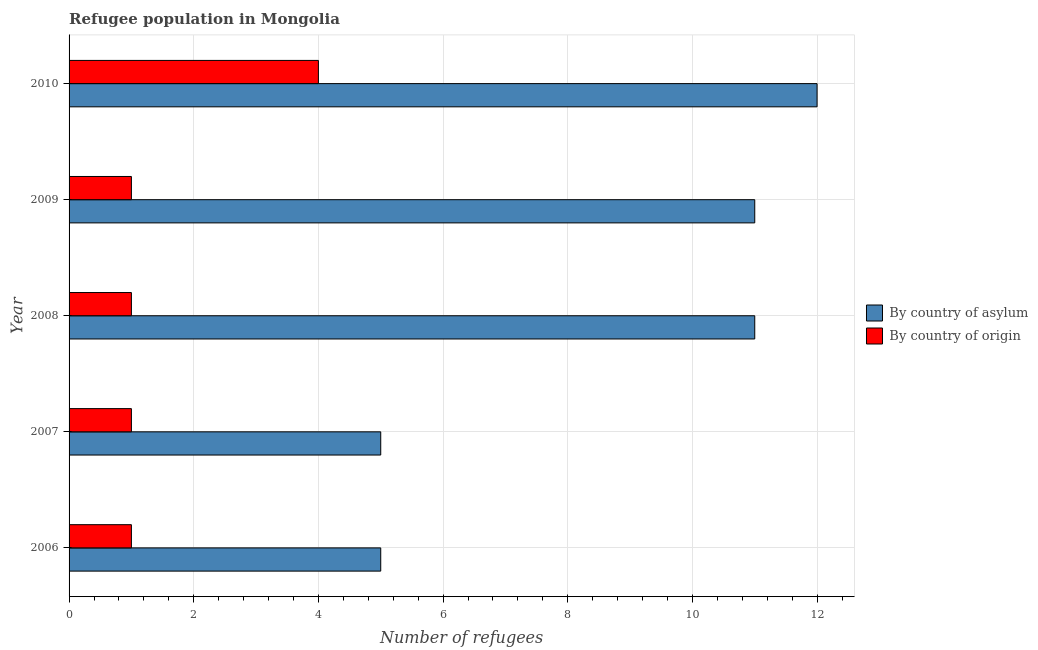How many different coloured bars are there?
Offer a very short reply. 2. How many groups of bars are there?
Offer a very short reply. 5. Are the number of bars per tick equal to the number of legend labels?
Ensure brevity in your answer.  Yes. How many bars are there on the 2nd tick from the top?
Keep it short and to the point. 2. In how many cases, is the number of bars for a given year not equal to the number of legend labels?
Your response must be concise. 0. What is the number of refugees by country of origin in 2008?
Your answer should be very brief. 1. Across all years, what is the maximum number of refugees by country of origin?
Your response must be concise. 4. Across all years, what is the minimum number of refugees by country of origin?
Give a very brief answer. 1. In which year was the number of refugees by country of origin maximum?
Your response must be concise. 2010. In which year was the number of refugees by country of asylum minimum?
Provide a short and direct response. 2006. What is the total number of refugees by country of asylum in the graph?
Your answer should be very brief. 44. What is the difference between the number of refugees by country of asylum in 2007 and that in 2008?
Your response must be concise. -6. What is the difference between the number of refugees by country of asylum in 2009 and the number of refugees by country of origin in 2010?
Offer a very short reply. 7. In the year 2006, what is the difference between the number of refugees by country of asylum and number of refugees by country of origin?
Your response must be concise. 4. In how many years, is the number of refugees by country of origin greater than 9.6 ?
Your answer should be compact. 0. Is the difference between the number of refugees by country of origin in 2009 and 2010 greater than the difference between the number of refugees by country of asylum in 2009 and 2010?
Ensure brevity in your answer.  No. What is the difference between the highest and the lowest number of refugees by country of asylum?
Keep it short and to the point. 7. What does the 2nd bar from the top in 2009 represents?
Offer a terse response. By country of asylum. What does the 1st bar from the bottom in 2006 represents?
Give a very brief answer. By country of asylum. How many bars are there?
Make the answer very short. 10. Are all the bars in the graph horizontal?
Your answer should be very brief. Yes. How many years are there in the graph?
Keep it short and to the point. 5. Does the graph contain any zero values?
Provide a succinct answer. No. Where does the legend appear in the graph?
Provide a succinct answer. Center right. How are the legend labels stacked?
Provide a succinct answer. Vertical. What is the title of the graph?
Your answer should be compact. Refugee population in Mongolia. What is the label or title of the X-axis?
Offer a very short reply. Number of refugees. What is the label or title of the Y-axis?
Keep it short and to the point. Year. What is the Number of refugees of By country of asylum in 2006?
Your answer should be compact. 5. What is the Number of refugees of By country of asylum in 2007?
Provide a succinct answer. 5. What is the Number of refugees in By country of origin in 2007?
Provide a succinct answer. 1. What is the Number of refugees of By country of origin in 2008?
Keep it short and to the point. 1. What is the Number of refugees in By country of asylum in 2009?
Your answer should be very brief. 11. What is the Number of refugees in By country of origin in 2009?
Provide a succinct answer. 1. What is the Number of refugees of By country of asylum in 2010?
Make the answer very short. 12. Across all years, what is the maximum Number of refugees in By country of asylum?
Provide a succinct answer. 12. Across all years, what is the maximum Number of refugees of By country of origin?
Ensure brevity in your answer.  4. Across all years, what is the minimum Number of refugees in By country of asylum?
Offer a very short reply. 5. Across all years, what is the minimum Number of refugees of By country of origin?
Provide a succinct answer. 1. What is the difference between the Number of refugees in By country of origin in 2006 and that in 2007?
Your answer should be very brief. 0. What is the difference between the Number of refugees in By country of asylum in 2006 and that in 2009?
Your answer should be very brief. -6. What is the difference between the Number of refugees in By country of asylum in 2006 and that in 2010?
Your response must be concise. -7. What is the difference between the Number of refugees of By country of origin in 2007 and that in 2008?
Ensure brevity in your answer.  0. What is the difference between the Number of refugees of By country of asylum in 2007 and that in 2009?
Your answer should be very brief. -6. What is the difference between the Number of refugees in By country of origin in 2007 and that in 2009?
Offer a very short reply. 0. What is the difference between the Number of refugees in By country of origin in 2007 and that in 2010?
Your answer should be compact. -3. What is the difference between the Number of refugees of By country of origin in 2008 and that in 2009?
Keep it short and to the point. 0. What is the difference between the Number of refugees in By country of asylum in 2009 and that in 2010?
Offer a terse response. -1. What is the difference between the Number of refugees of By country of origin in 2009 and that in 2010?
Provide a short and direct response. -3. What is the difference between the Number of refugees of By country of asylum in 2006 and the Number of refugees of By country of origin in 2007?
Your answer should be very brief. 4. What is the difference between the Number of refugees in By country of asylum in 2006 and the Number of refugees in By country of origin in 2008?
Provide a succinct answer. 4. What is the difference between the Number of refugees in By country of asylum in 2006 and the Number of refugees in By country of origin in 2009?
Offer a terse response. 4. What is the difference between the Number of refugees of By country of asylum in 2007 and the Number of refugees of By country of origin in 2010?
Give a very brief answer. 1. What is the difference between the Number of refugees of By country of asylum in 2009 and the Number of refugees of By country of origin in 2010?
Ensure brevity in your answer.  7. What is the average Number of refugees in By country of asylum per year?
Offer a terse response. 8.8. What is the average Number of refugees in By country of origin per year?
Your answer should be compact. 1.6. In the year 2007, what is the difference between the Number of refugees of By country of asylum and Number of refugees of By country of origin?
Give a very brief answer. 4. In the year 2008, what is the difference between the Number of refugees in By country of asylum and Number of refugees in By country of origin?
Give a very brief answer. 10. In the year 2010, what is the difference between the Number of refugees in By country of asylum and Number of refugees in By country of origin?
Provide a succinct answer. 8. What is the ratio of the Number of refugees of By country of asylum in 2006 to that in 2007?
Offer a very short reply. 1. What is the ratio of the Number of refugees in By country of origin in 2006 to that in 2007?
Keep it short and to the point. 1. What is the ratio of the Number of refugees of By country of asylum in 2006 to that in 2008?
Ensure brevity in your answer.  0.45. What is the ratio of the Number of refugees in By country of origin in 2006 to that in 2008?
Your answer should be very brief. 1. What is the ratio of the Number of refugees of By country of asylum in 2006 to that in 2009?
Make the answer very short. 0.45. What is the ratio of the Number of refugees in By country of asylum in 2006 to that in 2010?
Your answer should be compact. 0.42. What is the ratio of the Number of refugees in By country of origin in 2006 to that in 2010?
Make the answer very short. 0.25. What is the ratio of the Number of refugees in By country of asylum in 2007 to that in 2008?
Your answer should be compact. 0.45. What is the ratio of the Number of refugees of By country of asylum in 2007 to that in 2009?
Make the answer very short. 0.45. What is the ratio of the Number of refugees in By country of origin in 2007 to that in 2009?
Your answer should be very brief. 1. What is the ratio of the Number of refugees of By country of asylum in 2007 to that in 2010?
Give a very brief answer. 0.42. What is the ratio of the Number of refugees in By country of origin in 2007 to that in 2010?
Provide a succinct answer. 0.25. What is the ratio of the Number of refugees in By country of asylum in 2008 to that in 2010?
Your answer should be compact. 0.92. What is the ratio of the Number of refugees of By country of asylum in 2009 to that in 2010?
Your answer should be very brief. 0.92. What is the ratio of the Number of refugees of By country of origin in 2009 to that in 2010?
Offer a terse response. 0.25. 